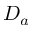<formula> <loc_0><loc_0><loc_500><loc_500>D _ { a }</formula> 